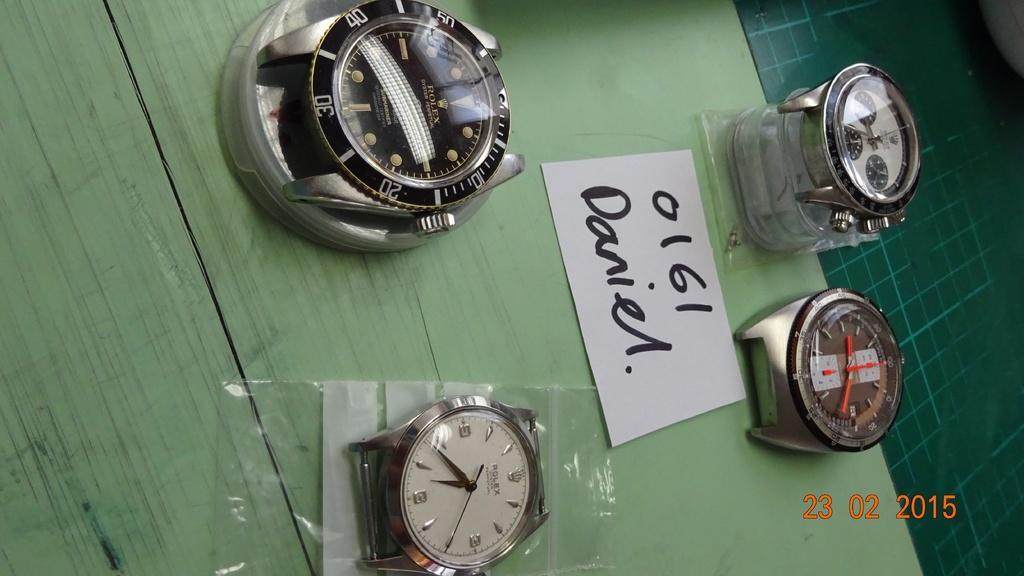In one or two sentences, can you explain what this image depicts? In this image, we can see watches and a paper are placed on the table. 